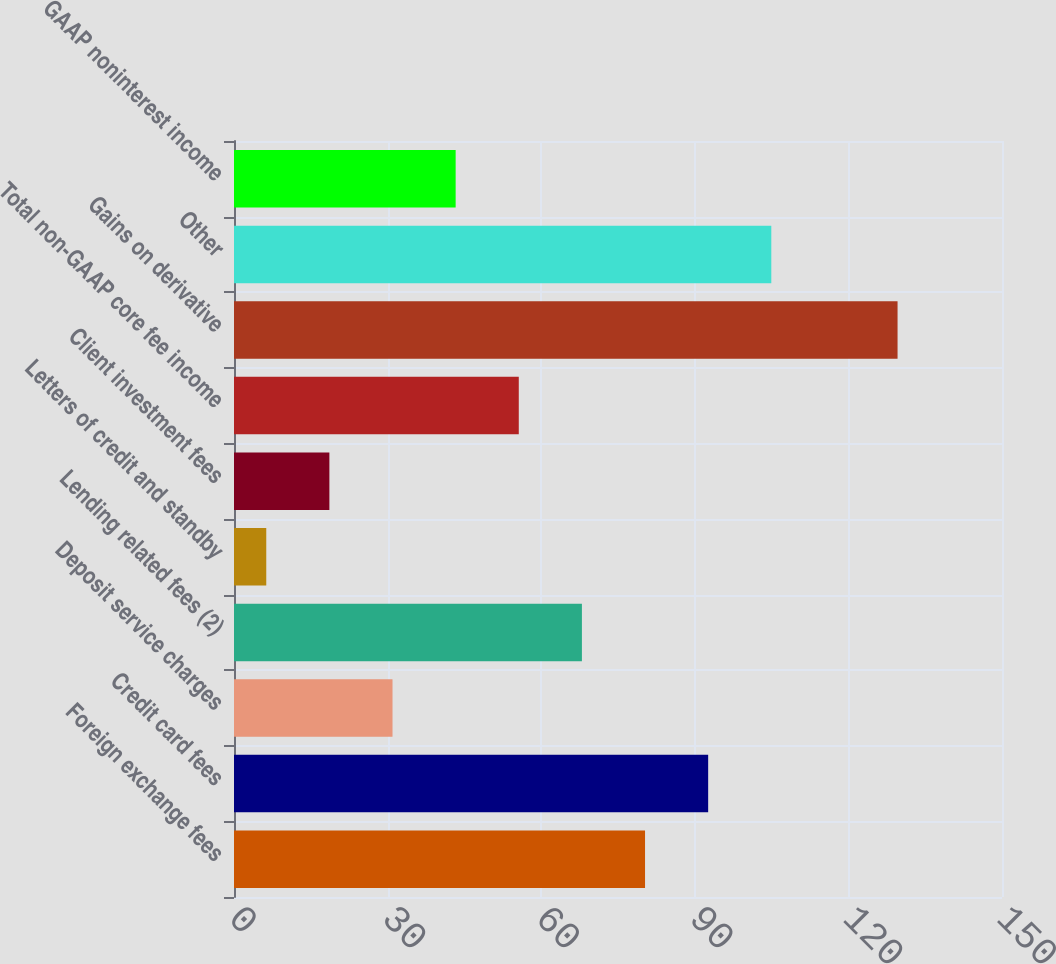Convert chart. <chart><loc_0><loc_0><loc_500><loc_500><bar_chart><fcel>Foreign exchange fees<fcel>Credit card fees<fcel>Deposit service charges<fcel>Lending related fees (2)<fcel>Letters of credit and standby<fcel>Client investment fees<fcel>Total non-GAAP core fee income<fcel>Gains on derivative<fcel>Other<fcel>GAAP noninterest income<nl><fcel>80.28<fcel>92.61<fcel>30.96<fcel>67.95<fcel>6.3<fcel>18.63<fcel>55.62<fcel>129.6<fcel>104.94<fcel>43.29<nl></chart> 